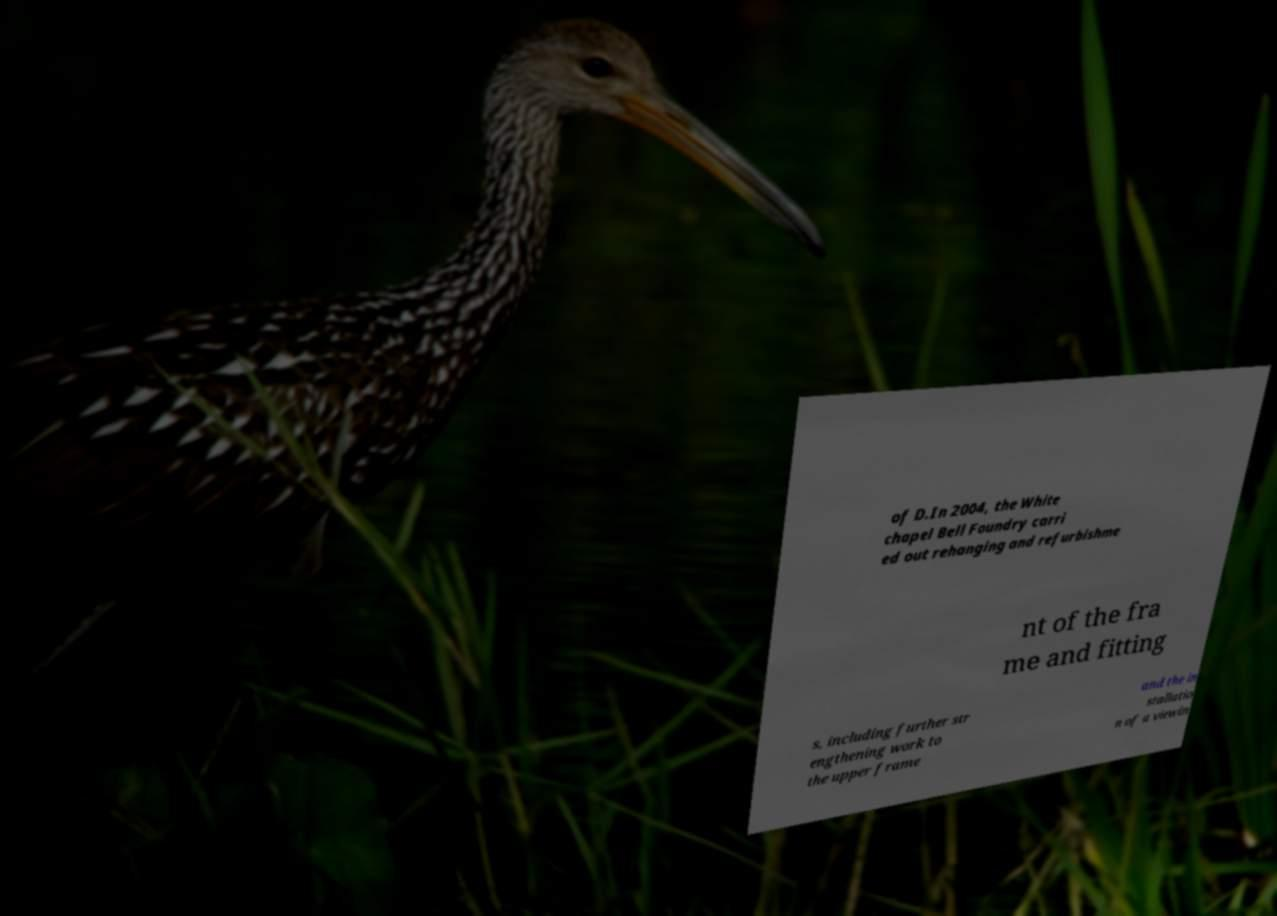Please read and relay the text visible in this image. What does it say? of D.In 2004, the White chapel Bell Foundry carri ed out rehanging and refurbishme nt of the fra me and fitting s, including further str engthening work to the upper frame and the in stallatio n of a viewin 